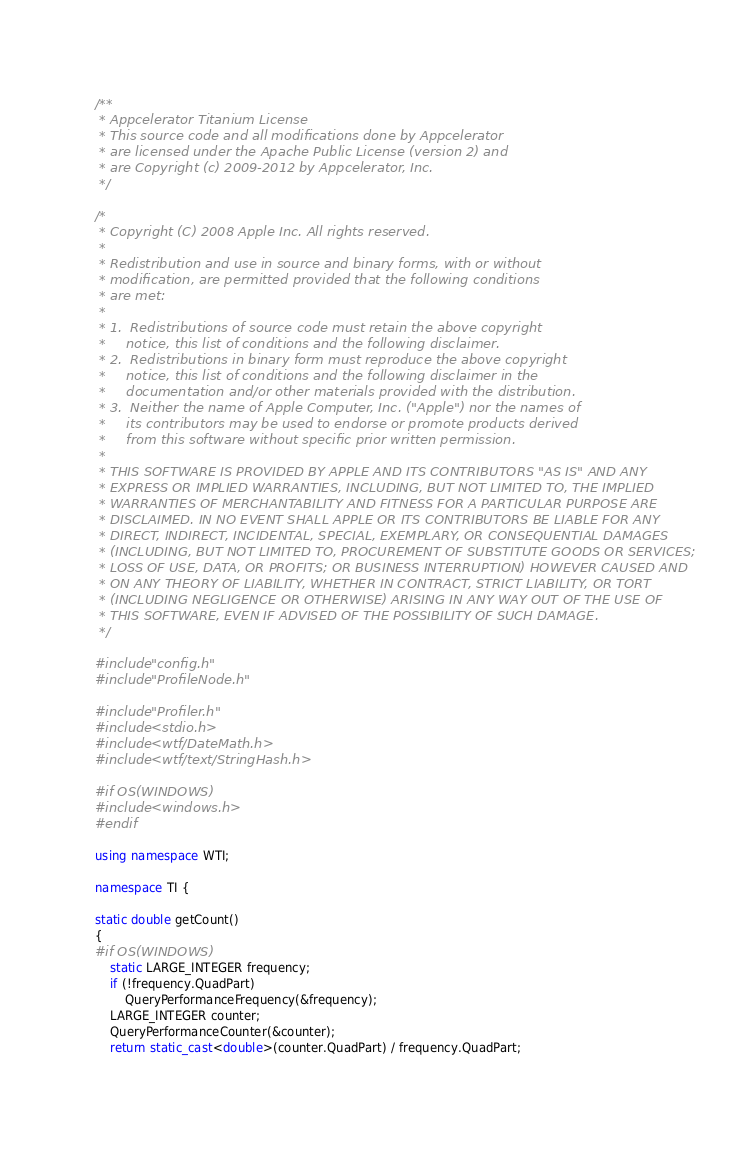<code> <loc_0><loc_0><loc_500><loc_500><_C++_>/**
 * Appcelerator Titanium License
 * This source code and all modifications done by Appcelerator
 * are licensed under the Apache Public License (version 2) and
 * are Copyright (c) 2009-2012 by Appcelerator, Inc.
 */

/*
 * Copyright (C) 2008 Apple Inc. All rights reserved.
 *
 * Redistribution and use in source and binary forms, with or without
 * modification, are permitted provided that the following conditions
 * are met:
 *
 * 1.  Redistributions of source code must retain the above copyright
 *     notice, this list of conditions and the following disclaimer.
 * 2.  Redistributions in binary form must reproduce the above copyright
 *     notice, this list of conditions and the following disclaimer in the
 *     documentation and/or other materials provided with the distribution.
 * 3.  Neither the name of Apple Computer, Inc. ("Apple") nor the names of
 *     its contributors may be used to endorse or promote products derived
 *     from this software without specific prior written permission.
 *
 * THIS SOFTWARE IS PROVIDED BY APPLE AND ITS CONTRIBUTORS "AS IS" AND ANY
 * EXPRESS OR IMPLIED WARRANTIES, INCLUDING, BUT NOT LIMITED TO, THE IMPLIED
 * WARRANTIES OF MERCHANTABILITY AND FITNESS FOR A PARTICULAR PURPOSE ARE
 * DISCLAIMED. IN NO EVENT SHALL APPLE OR ITS CONTRIBUTORS BE LIABLE FOR ANY
 * DIRECT, INDIRECT, INCIDENTAL, SPECIAL, EXEMPLARY, OR CONSEQUENTIAL DAMAGES
 * (INCLUDING, BUT NOT LIMITED TO, PROCUREMENT OF SUBSTITUTE GOODS OR SERVICES;
 * LOSS OF USE, DATA, OR PROFITS; OR BUSINESS INTERRUPTION) HOWEVER CAUSED AND
 * ON ANY THEORY OF LIABILITY, WHETHER IN CONTRACT, STRICT LIABILITY, OR TORT
 * (INCLUDING NEGLIGENCE OR OTHERWISE) ARISING IN ANY WAY OUT OF THE USE OF
 * THIS SOFTWARE, EVEN IF ADVISED OF THE POSSIBILITY OF SUCH DAMAGE.
 */

#include "config.h"
#include "ProfileNode.h"

#include "Profiler.h"
#include <stdio.h>
#include <wtf/DateMath.h>
#include <wtf/text/StringHash.h>

#if OS(WINDOWS)
#include <windows.h>
#endif

using namespace WTI;

namespace TI {

static double getCount()
{
#if OS(WINDOWS)
    static LARGE_INTEGER frequency;
    if (!frequency.QuadPart)
        QueryPerformanceFrequency(&frequency);
    LARGE_INTEGER counter;
    QueryPerformanceCounter(&counter);
    return static_cast<double>(counter.QuadPart) / frequency.QuadPart;</code> 